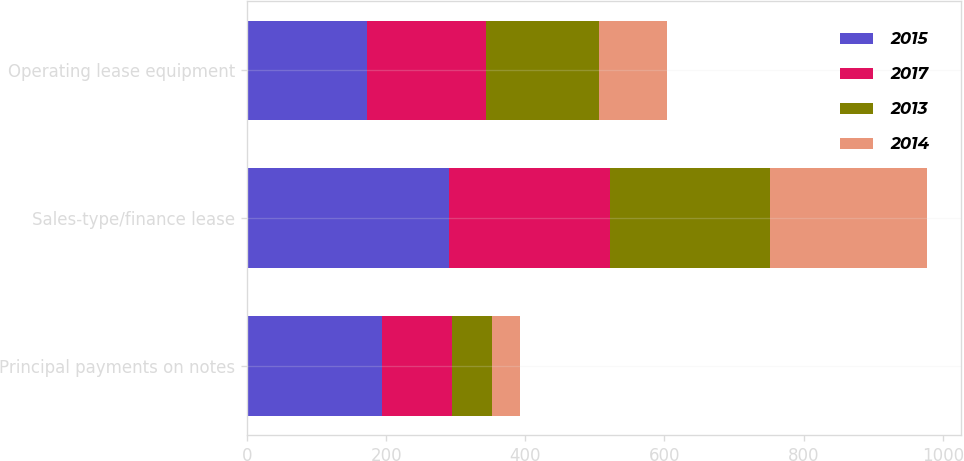<chart> <loc_0><loc_0><loc_500><loc_500><stacked_bar_chart><ecel><fcel>Principal payments on notes<fcel>Sales-type/finance lease<fcel>Operating lease equipment<nl><fcel>2015<fcel>194<fcel>290<fcel>172<nl><fcel>2017<fcel>101<fcel>231<fcel>172<nl><fcel>2013<fcel>57<fcel>230<fcel>162<nl><fcel>2014<fcel>41<fcel>226<fcel>97<nl></chart> 